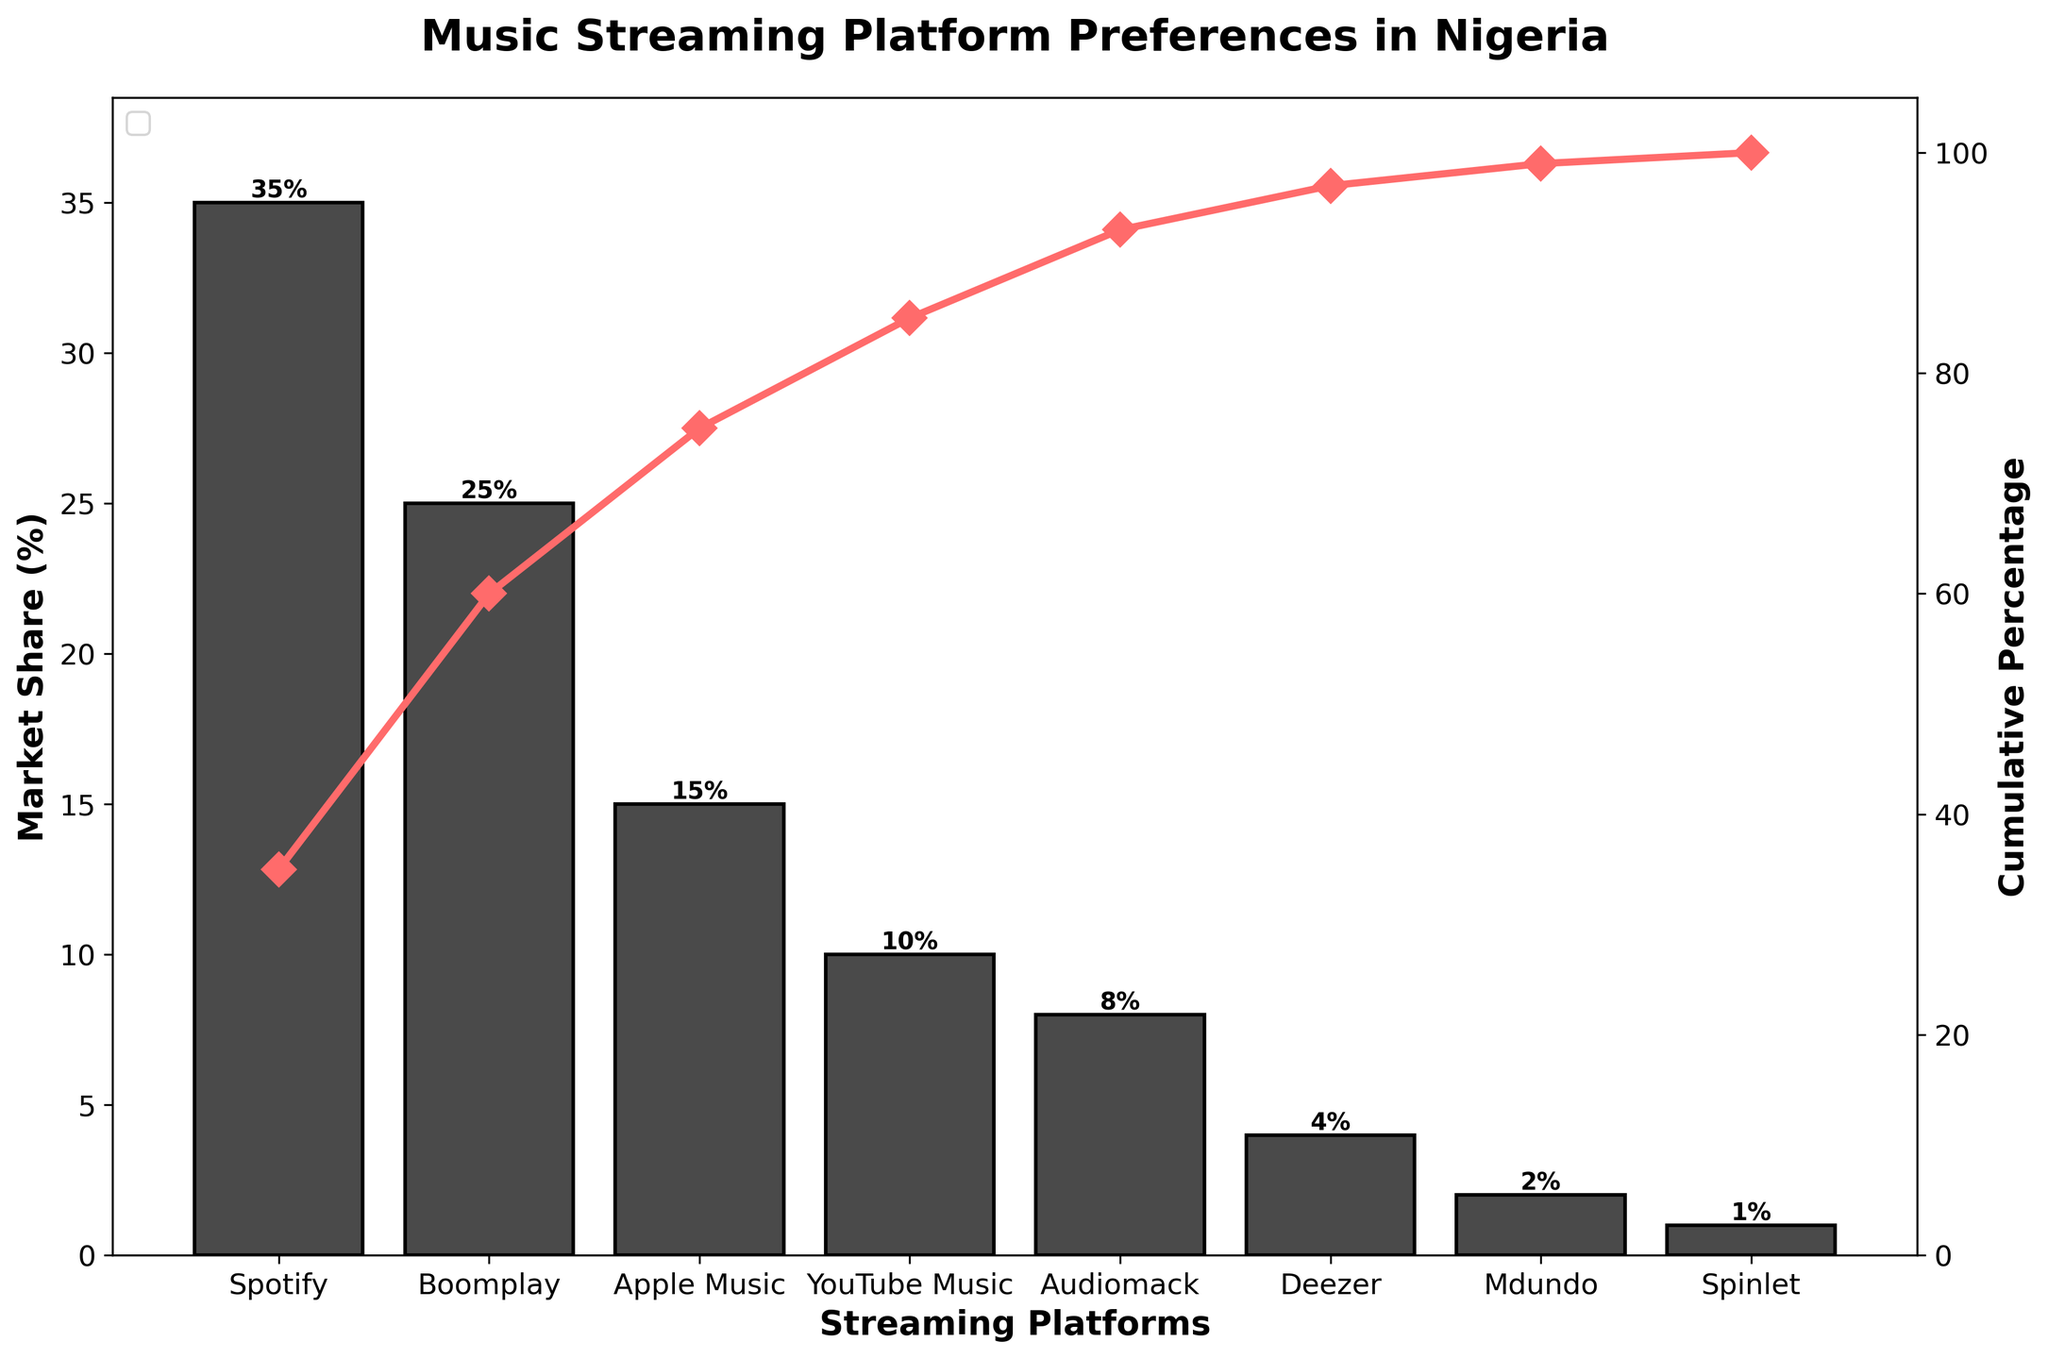What is the title of the chart? The title of the chart is located at the top and clearly states what the chart is about.
Answer: "Music Streaming Platform Preferences in Nigeria" How many streaming platforms are represented in the chart? Count the number of unique bars and data points represented along the x-axis.
Answer: 8 Which streaming platform has the highest market share? Identify the bar with the highest value on the y-axis, which represents the market share.
Answer: Spotify What is the cumulative market share percentage for the top three platforms? Find the cumulative percentage for the top three platforms (Spotify, Boomplay, Apple Music) from the cumulative line.
Answer: 75% What is the difference in market share between Spotify and Deezer? Subtract the market share of Deezer from that of Spotify. Spotify has 35%, and Deezer has 4%. So, the difference is 35% - 4% = 31%.
Answer: 31% Which platform has the smallest market share and what is its value? Look for the bar with the smallest height along the y-axis and note its market share.
Answer: Spinlet, 1% Which platforms together make up more than 80% of the market share? Identify the platforms by adding their individual market shares until the cumulative percentage exceeds 80%.
Answer: Spotify, Boomplay, Apple Music, YouTube Music What is the cumulative percentage when adding Audiomack to the previous platforms? Add Audiomack's market share to the cumulative sum of Spotify, Boomplay, Apple Music, and YouTube Music. The cumulative percentage up to YouTube Music is 85%, so adding Audiomack's 8% makes it 85%.
Answer: 93% Comparing Boomplay and Apple Music, which one has a higher market share and by how much? Subtract Apple Music's market share from Boomplay's. Boomplay has 25%, and Apple Music has 15%, so the difference is 25% - 15% = 10%.
Answer: Boomplay by 10% At which platform does the cumulative percentage exceed 50%? Identify the platform at which the cumulative percentage line first crosses or exceeds 50%.
Answer: Boomplay 